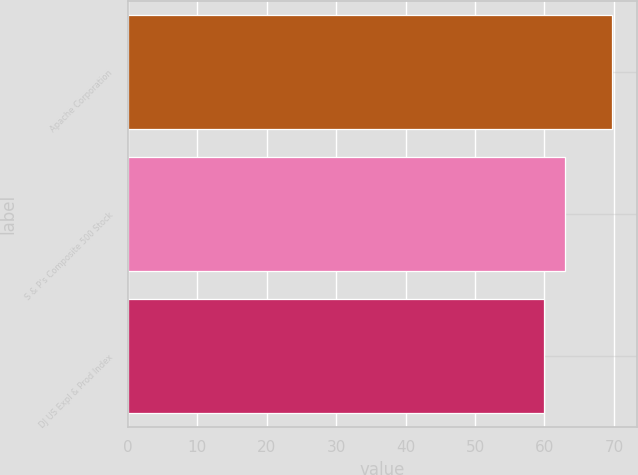Convert chart to OTSL. <chart><loc_0><loc_0><loc_500><loc_500><bar_chart><fcel>Apache Corporation<fcel>S & P's Composite 500 Stock<fcel>DJ US Expl & Prod Index<nl><fcel>69.77<fcel>63<fcel>59.88<nl></chart> 